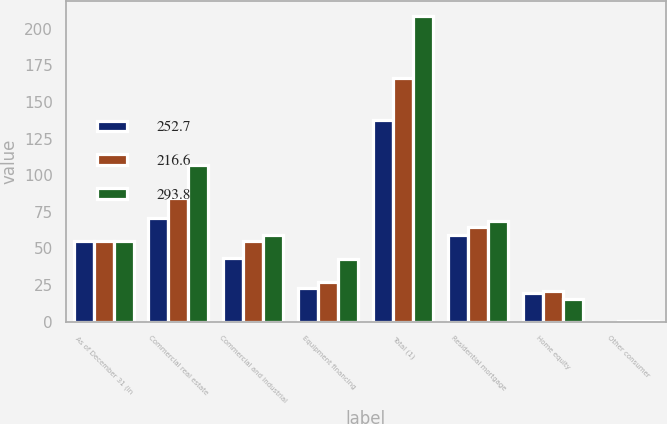Convert chart to OTSL. <chart><loc_0><loc_0><loc_500><loc_500><stacked_bar_chart><ecel><fcel>As of December 31 (in<fcel>Commercial real estate<fcel>Commercial and industrial<fcel>Equipment financing<fcel>Total (1)<fcel>Residential mortgage<fcel>Home equity<fcel>Other consumer<nl><fcel>252.7<fcel>54.8<fcel>70.8<fcel>43.8<fcel>23.2<fcel>137.8<fcel>58.9<fcel>19.8<fcel>0.1<nl><fcel>216.6<fcel>54.8<fcel>84.4<fcel>54.8<fcel>27.2<fcel>166.4<fcel>65<fcel>21<fcel>0.3<nl><fcel>293.8<fcel>54.8<fcel>106.7<fcel>59.2<fcel>42.9<fcel>208.8<fcel>68.9<fcel>15.8<fcel>0.3<nl></chart> 